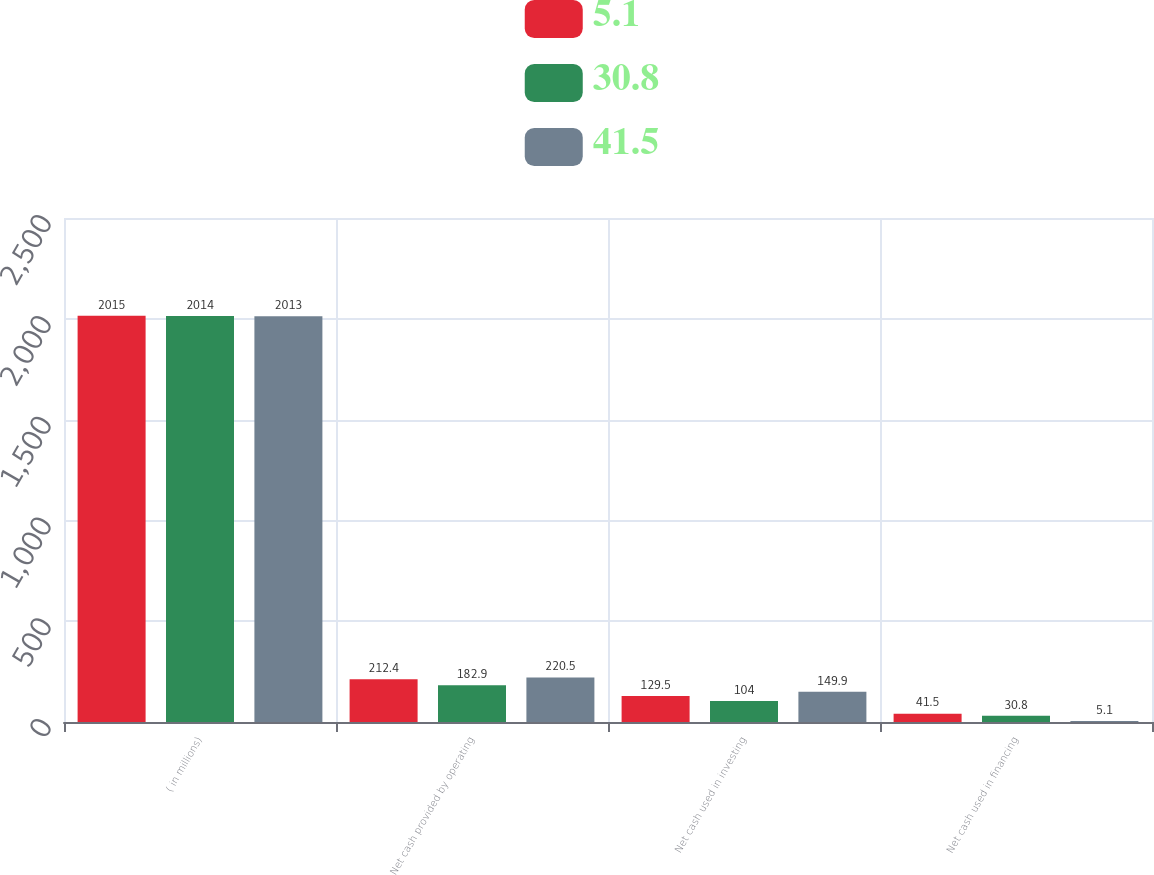Convert chart to OTSL. <chart><loc_0><loc_0><loc_500><loc_500><stacked_bar_chart><ecel><fcel>( in millions)<fcel>Net cash provided by operating<fcel>Net cash used in investing<fcel>Net cash used in financing<nl><fcel>5.1<fcel>2015<fcel>212.4<fcel>129.5<fcel>41.5<nl><fcel>30.8<fcel>2014<fcel>182.9<fcel>104<fcel>30.8<nl><fcel>41.5<fcel>2013<fcel>220.5<fcel>149.9<fcel>5.1<nl></chart> 